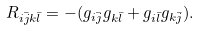<formula> <loc_0><loc_0><loc_500><loc_500>R _ { i \bar { j } k \bar { l } } = - ( g _ { i \bar { j } } g _ { k \bar { l } } + g _ { i \bar { l } } g _ { k \bar { j } } ) .</formula> 